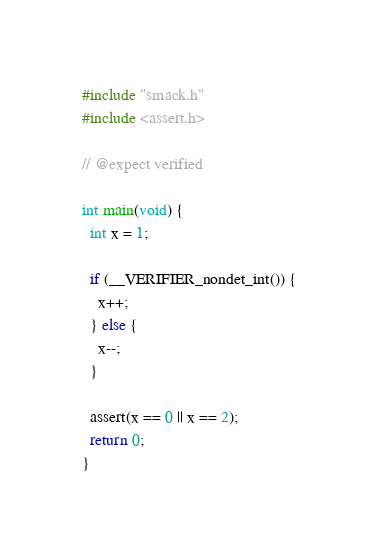<code> <loc_0><loc_0><loc_500><loc_500><_C_>#include "smack.h"
#include <assert.h>

// @expect verified

int main(void) {
  int x = 1;

  if (__VERIFIER_nondet_int()) {
    x++;
  } else {
    x--;
  }

  assert(x == 0 || x == 2);
  return 0;
}
</code> 